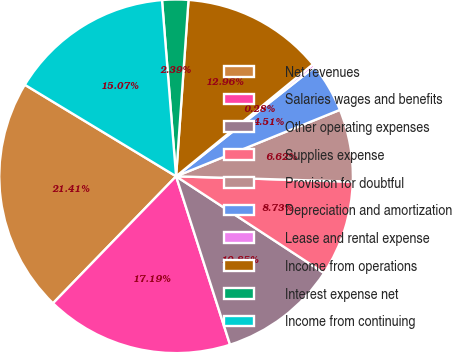<chart> <loc_0><loc_0><loc_500><loc_500><pie_chart><fcel>Net revenues<fcel>Salaries wages and benefits<fcel>Other operating expenses<fcel>Supplies expense<fcel>Provision for doubtful<fcel>Depreciation and amortization<fcel>Lease and rental expense<fcel>Income from operations<fcel>Interest expense net<fcel>Income from continuing<nl><fcel>21.41%<fcel>17.19%<fcel>10.85%<fcel>8.73%<fcel>6.62%<fcel>4.51%<fcel>0.28%<fcel>12.96%<fcel>2.39%<fcel>15.07%<nl></chart> 